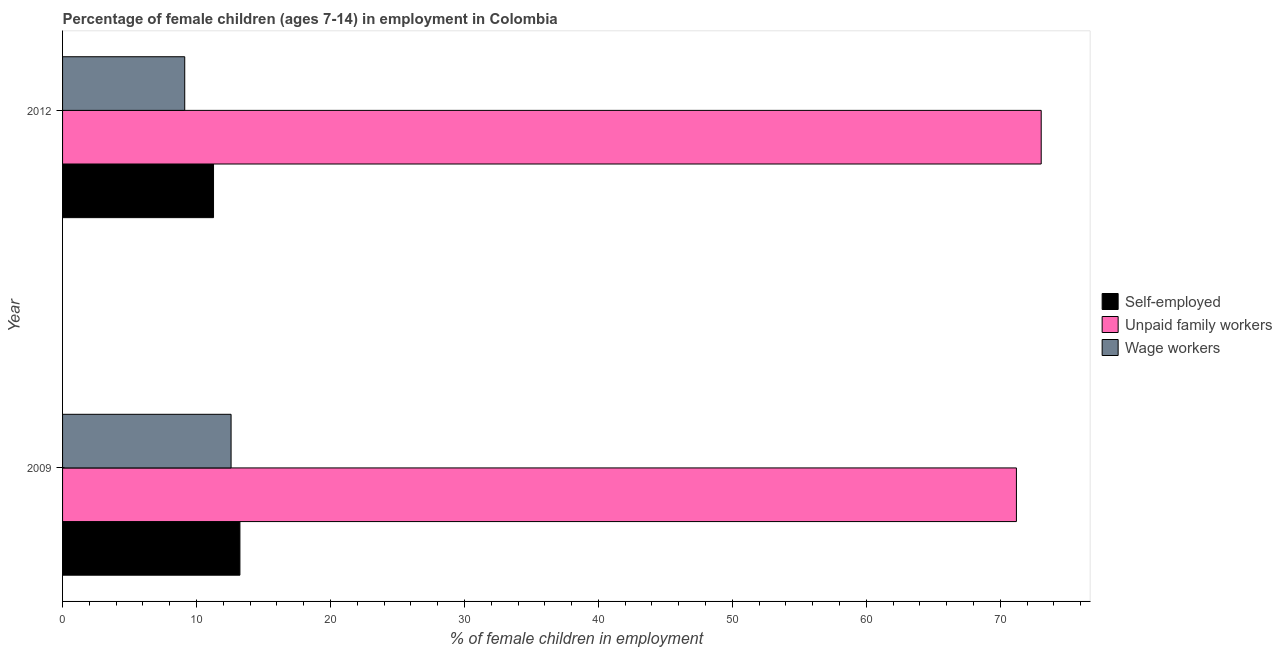How many bars are there on the 2nd tick from the top?
Offer a terse response. 3. In how many cases, is the number of bars for a given year not equal to the number of legend labels?
Your response must be concise. 0. What is the percentage of children employed as wage workers in 2009?
Give a very brief answer. 12.58. Across all years, what is the maximum percentage of children employed as unpaid family workers?
Make the answer very short. 73.06. Across all years, what is the minimum percentage of children employed as unpaid family workers?
Keep it short and to the point. 71.21. In which year was the percentage of children employed as unpaid family workers maximum?
Your answer should be compact. 2012. What is the total percentage of self employed children in the graph?
Make the answer very short. 24.51. What is the difference between the percentage of self employed children in 2009 and that in 2012?
Make the answer very short. 1.97. What is the difference between the percentage of children employed as unpaid family workers in 2009 and the percentage of children employed as wage workers in 2012?
Give a very brief answer. 62.09. What is the average percentage of children employed as wage workers per year?
Offer a terse response. 10.85. In the year 2009, what is the difference between the percentage of children employed as unpaid family workers and percentage of children employed as wage workers?
Provide a succinct answer. 58.63. What is the ratio of the percentage of children employed as unpaid family workers in 2009 to that in 2012?
Make the answer very short. 0.97. What does the 1st bar from the top in 2009 represents?
Give a very brief answer. Wage workers. What does the 2nd bar from the bottom in 2009 represents?
Offer a very short reply. Unpaid family workers. Is it the case that in every year, the sum of the percentage of self employed children and percentage of children employed as unpaid family workers is greater than the percentage of children employed as wage workers?
Provide a succinct answer. Yes. How many bars are there?
Offer a very short reply. 6. What is the difference between two consecutive major ticks on the X-axis?
Offer a very short reply. 10. Does the graph contain any zero values?
Provide a succinct answer. No. Where does the legend appear in the graph?
Your response must be concise. Center right. What is the title of the graph?
Your response must be concise. Percentage of female children (ages 7-14) in employment in Colombia. What is the label or title of the X-axis?
Your answer should be very brief. % of female children in employment. What is the % of female children in employment in Self-employed in 2009?
Offer a very short reply. 13.24. What is the % of female children in employment in Unpaid family workers in 2009?
Offer a terse response. 71.21. What is the % of female children in employment in Wage workers in 2009?
Offer a very short reply. 12.58. What is the % of female children in employment of Self-employed in 2012?
Ensure brevity in your answer.  11.27. What is the % of female children in employment of Unpaid family workers in 2012?
Provide a succinct answer. 73.06. What is the % of female children in employment of Wage workers in 2012?
Ensure brevity in your answer.  9.12. Across all years, what is the maximum % of female children in employment in Self-employed?
Make the answer very short. 13.24. Across all years, what is the maximum % of female children in employment of Unpaid family workers?
Make the answer very short. 73.06. Across all years, what is the maximum % of female children in employment of Wage workers?
Offer a terse response. 12.58. Across all years, what is the minimum % of female children in employment in Self-employed?
Offer a terse response. 11.27. Across all years, what is the minimum % of female children in employment in Unpaid family workers?
Offer a very short reply. 71.21. Across all years, what is the minimum % of female children in employment of Wage workers?
Provide a short and direct response. 9.12. What is the total % of female children in employment in Self-employed in the graph?
Offer a very short reply. 24.51. What is the total % of female children in employment of Unpaid family workers in the graph?
Keep it short and to the point. 144.27. What is the total % of female children in employment of Wage workers in the graph?
Your response must be concise. 21.7. What is the difference between the % of female children in employment in Self-employed in 2009 and that in 2012?
Provide a short and direct response. 1.97. What is the difference between the % of female children in employment of Unpaid family workers in 2009 and that in 2012?
Provide a short and direct response. -1.85. What is the difference between the % of female children in employment in Wage workers in 2009 and that in 2012?
Your answer should be very brief. 3.46. What is the difference between the % of female children in employment of Self-employed in 2009 and the % of female children in employment of Unpaid family workers in 2012?
Provide a succinct answer. -59.82. What is the difference between the % of female children in employment of Self-employed in 2009 and the % of female children in employment of Wage workers in 2012?
Make the answer very short. 4.12. What is the difference between the % of female children in employment of Unpaid family workers in 2009 and the % of female children in employment of Wage workers in 2012?
Your response must be concise. 62.09. What is the average % of female children in employment in Self-employed per year?
Provide a succinct answer. 12.26. What is the average % of female children in employment of Unpaid family workers per year?
Offer a very short reply. 72.14. What is the average % of female children in employment in Wage workers per year?
Your response must be concise. 10.85. In the year 2009, what is the difference between the % of female children in employment in Self-employed and % of female children in employment in Unpaid family workers?
Your answer should be very brief. -57.97. In the year 2009, what is the difference between the % of female children in employment in Self-employed and % of female children in employment in Wage workers?
Give a very brief answer. 0.66. In the year 2009, what is the difference between the % of female children in employment of Unpaid family workers and % of female children in employment of Wage workers?
Ensure brevity in your answer.  58.63. In the year 2012, what is the difference between the % of female children in employment in Self-employed and % of female children in employment in Unpaid family workers?
Keep it short and to the point. -61.79. In the year 2012, what is the difference between the % of female children in employment of Self-employed and % of female children in employment of Wage workers?
Your answer should be very brief. 2.15. In the year 2012, what is the difference between the % of female children in employment of Unpaid family workers and % of female children in employment of Wage workers?
Provide a short and direct response. 63.94. What is the ratio of the % of female children in employment in Self-employed in 2009 to that in 2012?
Ensure brevity in your answer.  1.17. What is the ratio of the % of female children in employment of Unpaid family workers in 2009 to that in 2012?
Offer a terse response. 0.97. What is the ratio of the % of female children in employment of Wage workers in 2009 to that in 2012?
Make the answer very short. 1.38. What is the difference between the highest and the second highest % of female children in employment of Self-employed?
Offer a terse response. 1.97. What is the difference between the highest and the second highest % of female children in employment in Unpaid family workers?
Give a very brief answer. 1.85. What is the difference between the highest and the second highest % of female children in employment of Wage workers?
Give a very brief answer. 3.46. What is the difference between the highest and the lowest % of female children in employment in Self-employed?
Ensure brevity in your answer.  1.97. What is the difference between the highest and the lowest % of female children in employment of Unpaid family workers?
Provide a short and direct response. 1.85. What is the difference between the highest and the lowest % of female children in employment in Wage workers?
Your response must be concise. 3.46. 